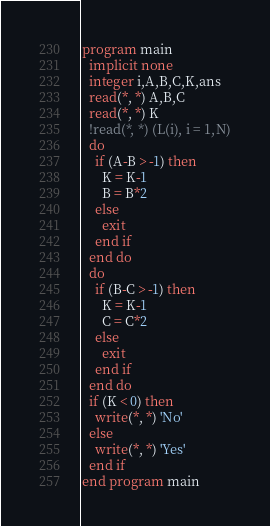Convert code to text. <code><loc_0><loc_0><loc_500><loc_500><_FORTRAN_>program main
  implicit none
  integer i,A,B,C,K,ans
  read(*, *) A,B,C
  read(*, *) K
  !read(*, *) (L(i), i = 1,N)
  do
    if (A-B > -1) then
      K = K-1
      B = B*2
    else
      exit
    end if
  end do
  do
    if (B-C > -1) then
      K = K-1
      C = C*2
    else
      exit
    end if
  end do
  if (K < 0) then
    write(*, *) 'No'
  else
    write(*, *) 'Yes'
  end if
end program main
</code> 